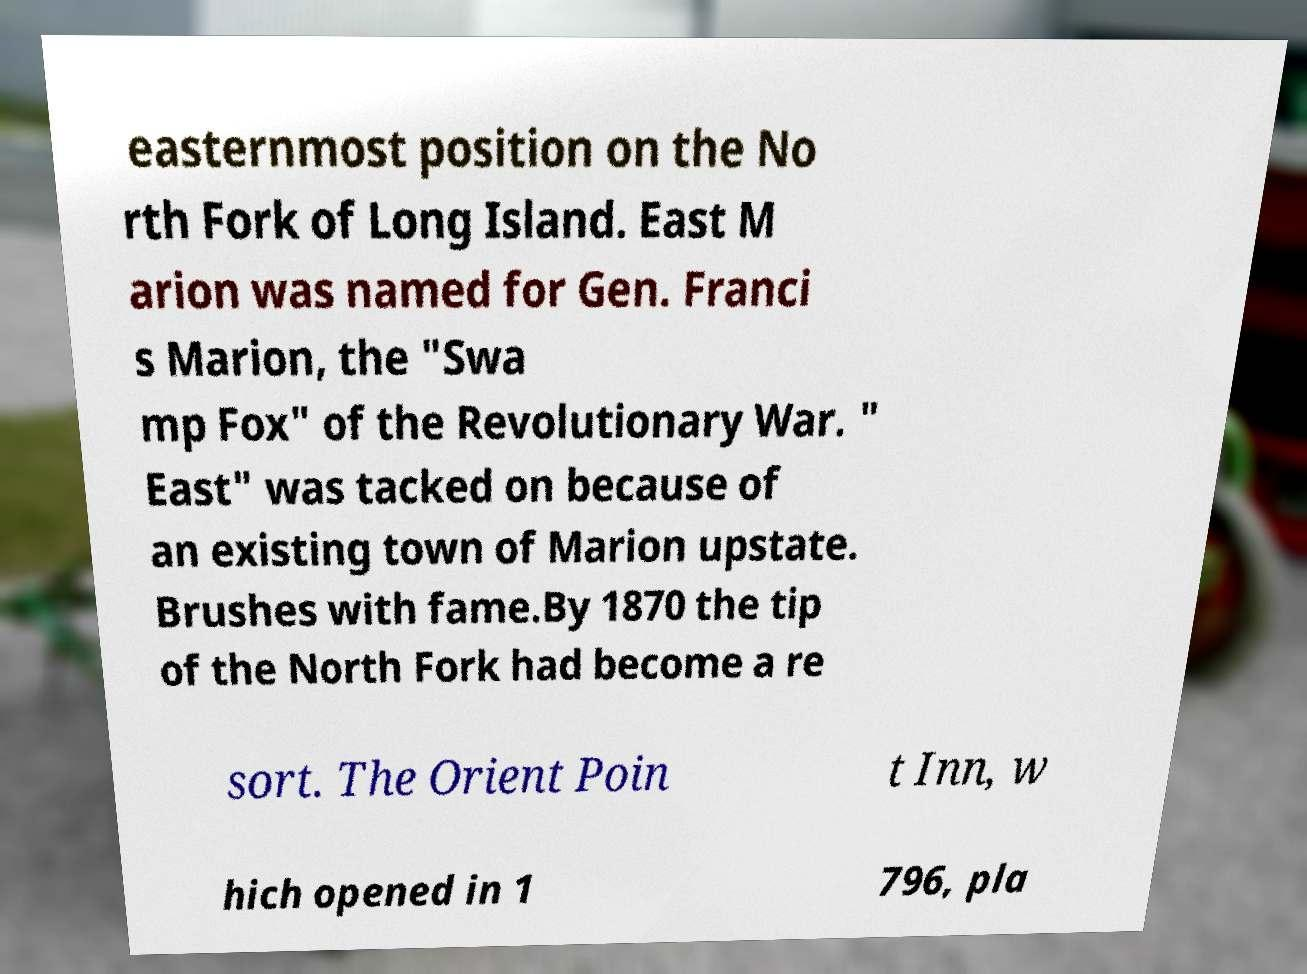There's text embedded in this image that I need extracted. Can you transcribe it verbatim? easternmost position on the No rth Fork of Long Island. East M arion was named for Gen. Franci s Marion, the "Swa mp Fox" of the Revolutionary War. " East" was tacked on because of an existing town of Marion upstate. Brushes with fame.By 1870 the tip of the North Fork had become a re sort. The Orient Poin t Inn, w hich opened in 1 796, pla 